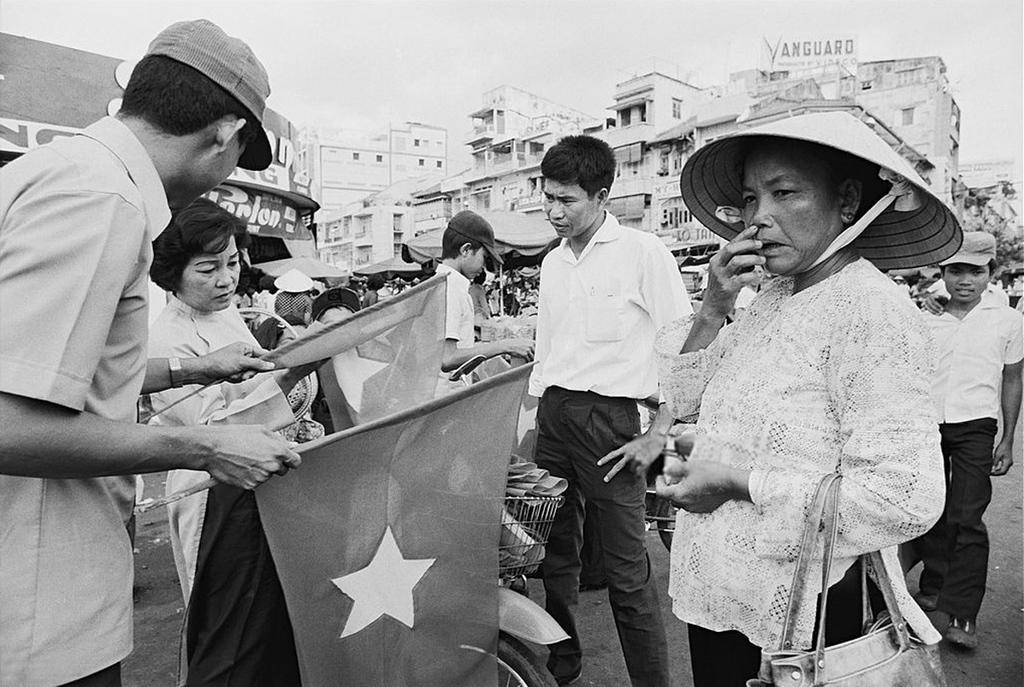Could you give a brief overview of what you see in this image? In this picture we can see some people are standing, a man on the left side is holding flags, in the background there are some buildings and tents, we can see the sky at the top of the picture, a person in the front is carrying a bag, it is a black and white image. 